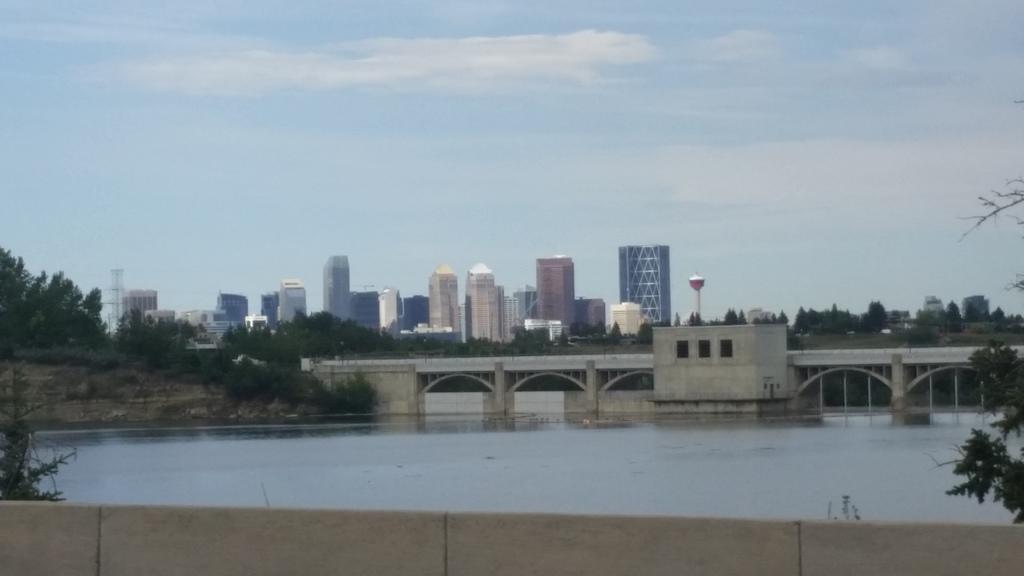Please provide a concise description of this image. These are the buildings. I can see the trees. This looks like a bridge. I think these are the water. At the bottom of the image, that looks like a wall. These are the clouds in the sky. 